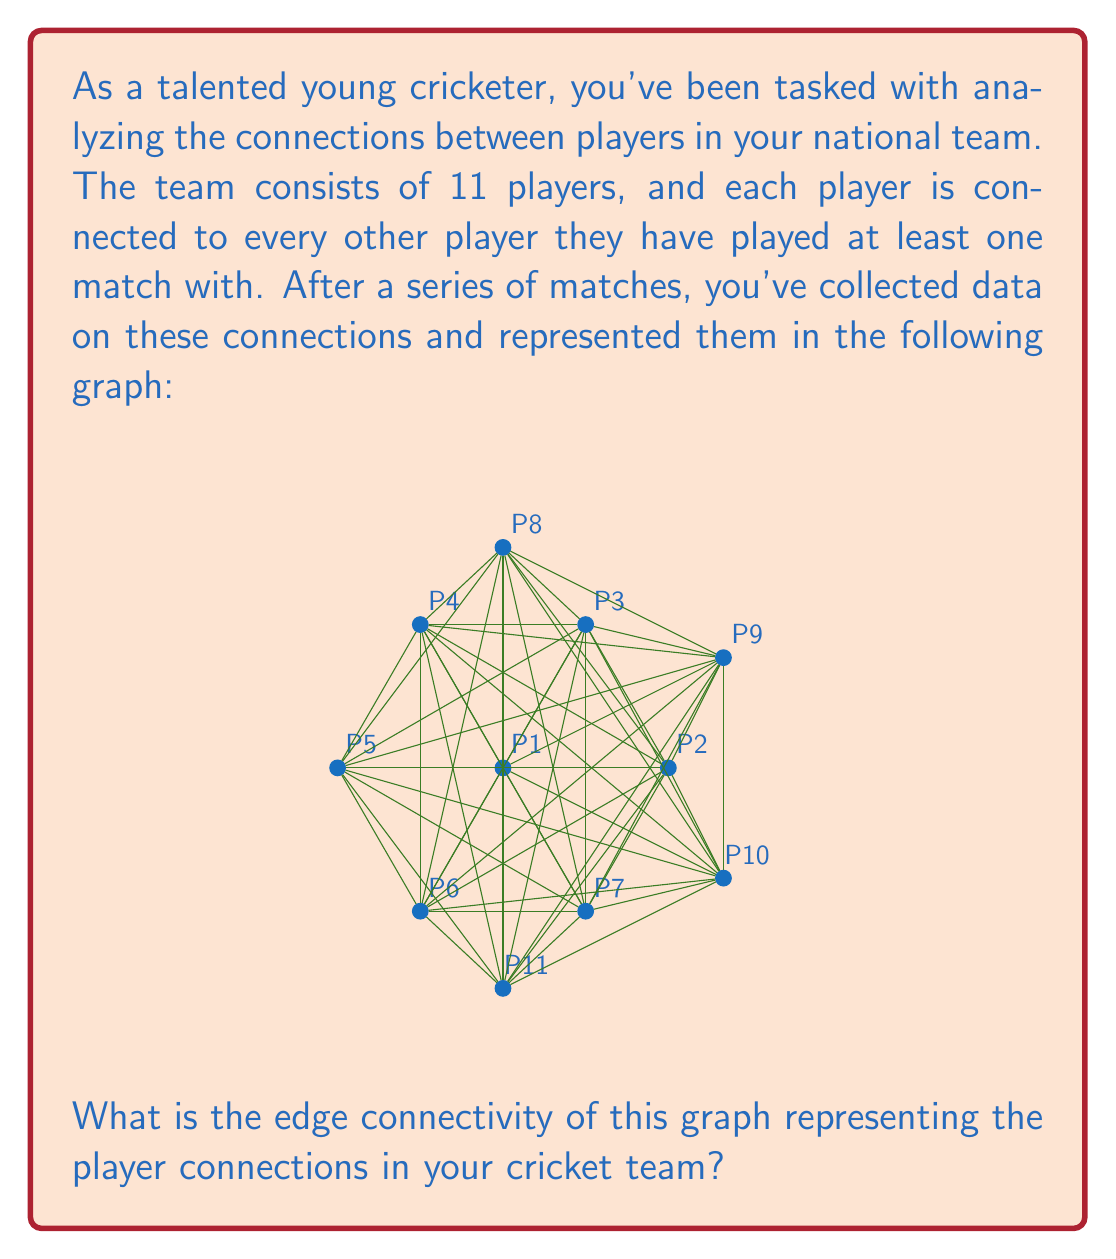Could you help me with this problem? To find the edge connectivity of the graph, we need to determine the minimum number of edges that need to be removed to disconnect the graph. Let's approach this step-by-step:

1) First, recall that edge connectivity is always less than or equal to the minimum degree of the graph.

2) Observe the graph:
   - Most vertices have a high degree (connected to many other vertices).
   - P1 (center) is connected to all other vertices.
   - P11 (bottom) seems to have the least connections.

3) Count the degree of P11:
   - P11 is connected to P1, P3, P5, P7, and P9.
   - Degree of P11 = 5

4) Check if removing these 5 edges disconnects the graph:
   - If we remove the 5 edges connected to P11, it becomes isolated.
   - The rest of the graph remains connected.

5) Verify if it's possible to disconnect the graph by removing fewer edges:
   - Removing any 4 edges will not disconnect the graph due to the high connectivity between other vertices.

6) Therefore, the minimum number of edges that need to be removed to disconnect the graph is 5.

This means the edge connectivity of the graph is 5.
Answer: 5 